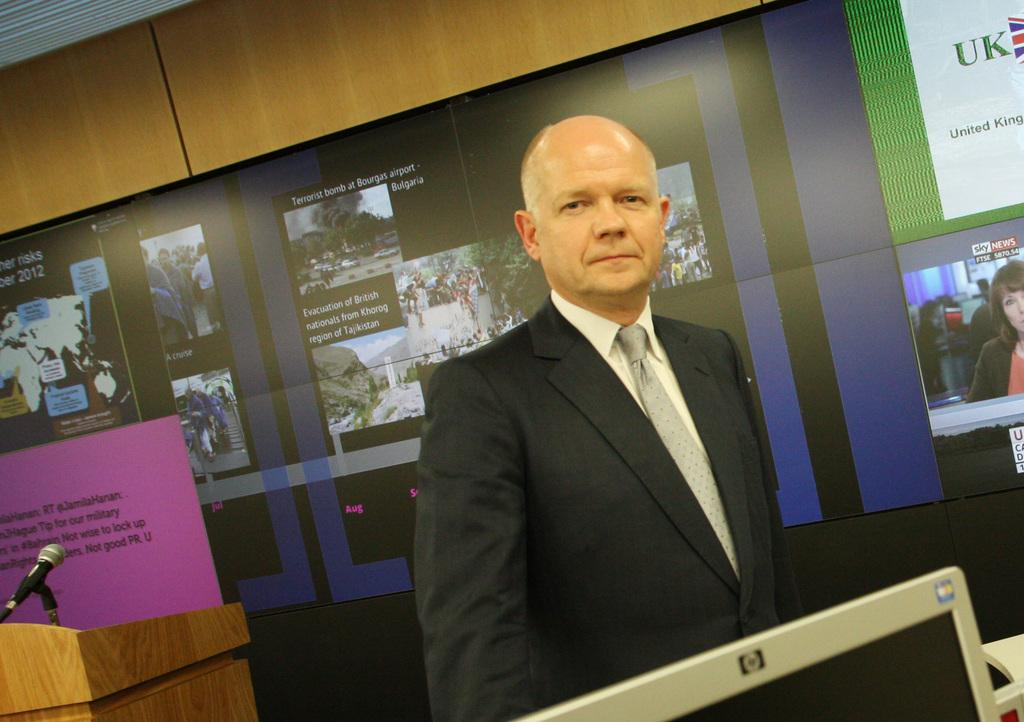What is the person in the image doing? There is a person standing in the image. What is the person wearing? The person is wearing a suit. What can be seen on the left side of the image? There is a microphone and its stand at the left side of the image. What is visible in the background of the image? There are posters visible in the background of the image. How many worms can be seen sleeping on the person's suit in the image? There are no worms present in the image, and the person is standing, not sleeping. 